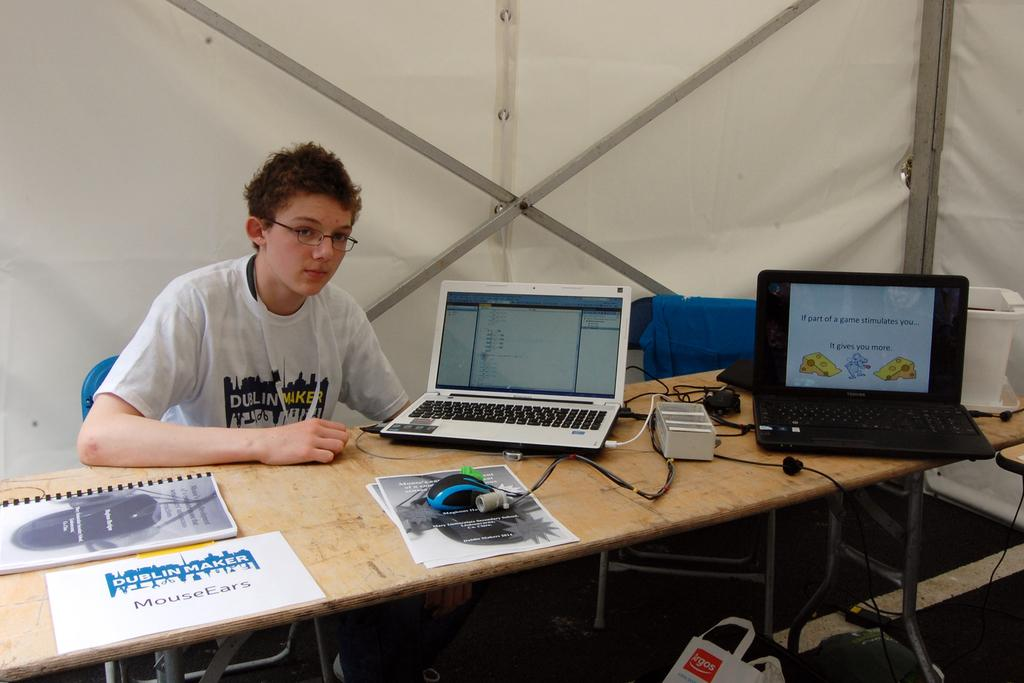Provide a one-sentence caption for the provided image. A young man sitting at a desk advertising something called Mouse Ears. 